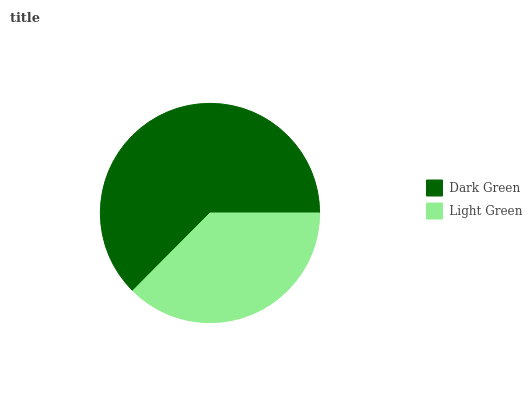Is Light Green the minimum?
Answer yes or no. Yes. Is Dark Green the maximum?
Answer yes or no. Yes. Is Light Green the maximum?
Answer yes or no. No. Is Dark Green greater than Light Green?
Answer yes or no. Yes. Is Light Green less than Dark Green?
Answer yes or no. Yes. Is Light Green greater than Dark Green?
Answer yes or no. No. Is Dark Green less than Light Green?
Answer yes or no. No. Is Dark Green the high median?
Answer yes or no. Yes. Is Light Green the low median?
Answer yes or no. Yes. Is Light Green the high median?
Answer yes or no. No. Is Dark Green the low median?
Answer yes or no. No. 